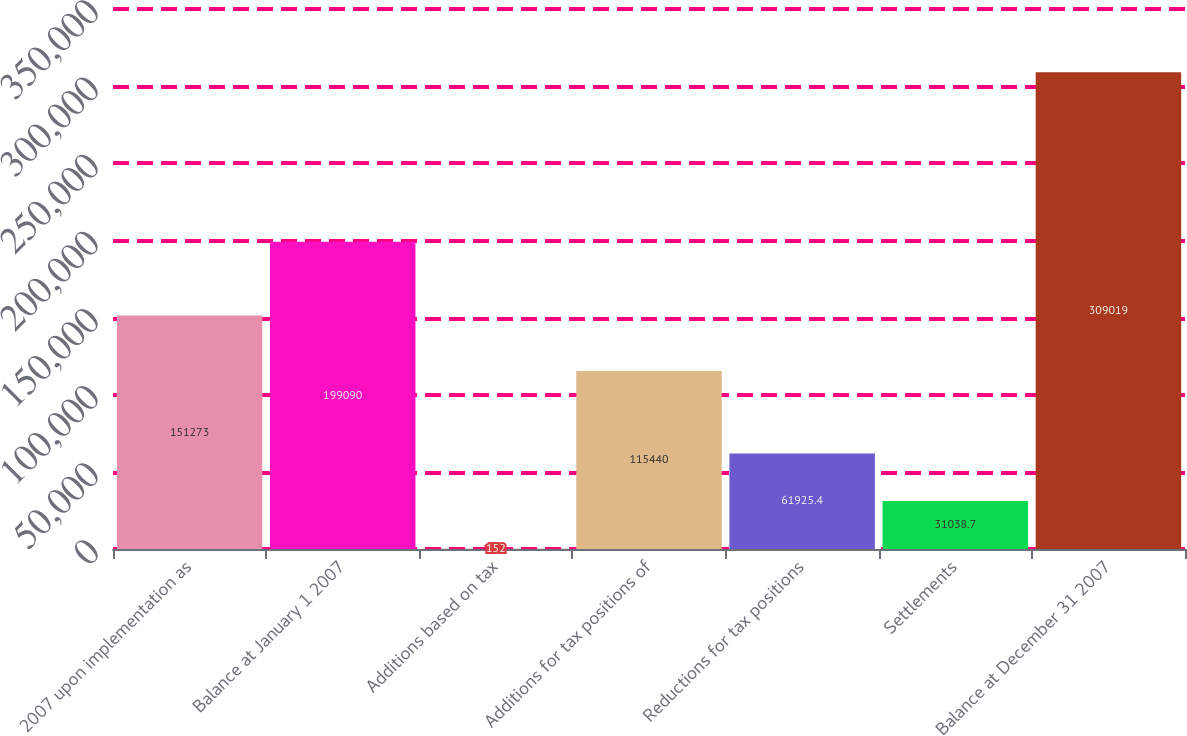Convert chart. <chart><loc_0><loc_0><loc_500><loc_500><bar_chart><fcel>2007 upon implementation as<fcel>Balance at January 1 2007<fcel>Additions based on tax<fcel>Additions for tax positions of<fcel>Reductions for tax positions<fcel>Settlements<fcel>Balance at December 31 2007<nl><fcel>151273<fcel>199090<fcel>152<fcel>115440<fcel>61925.4<fcel>31038.7<fcel>309019<nl></chart> 